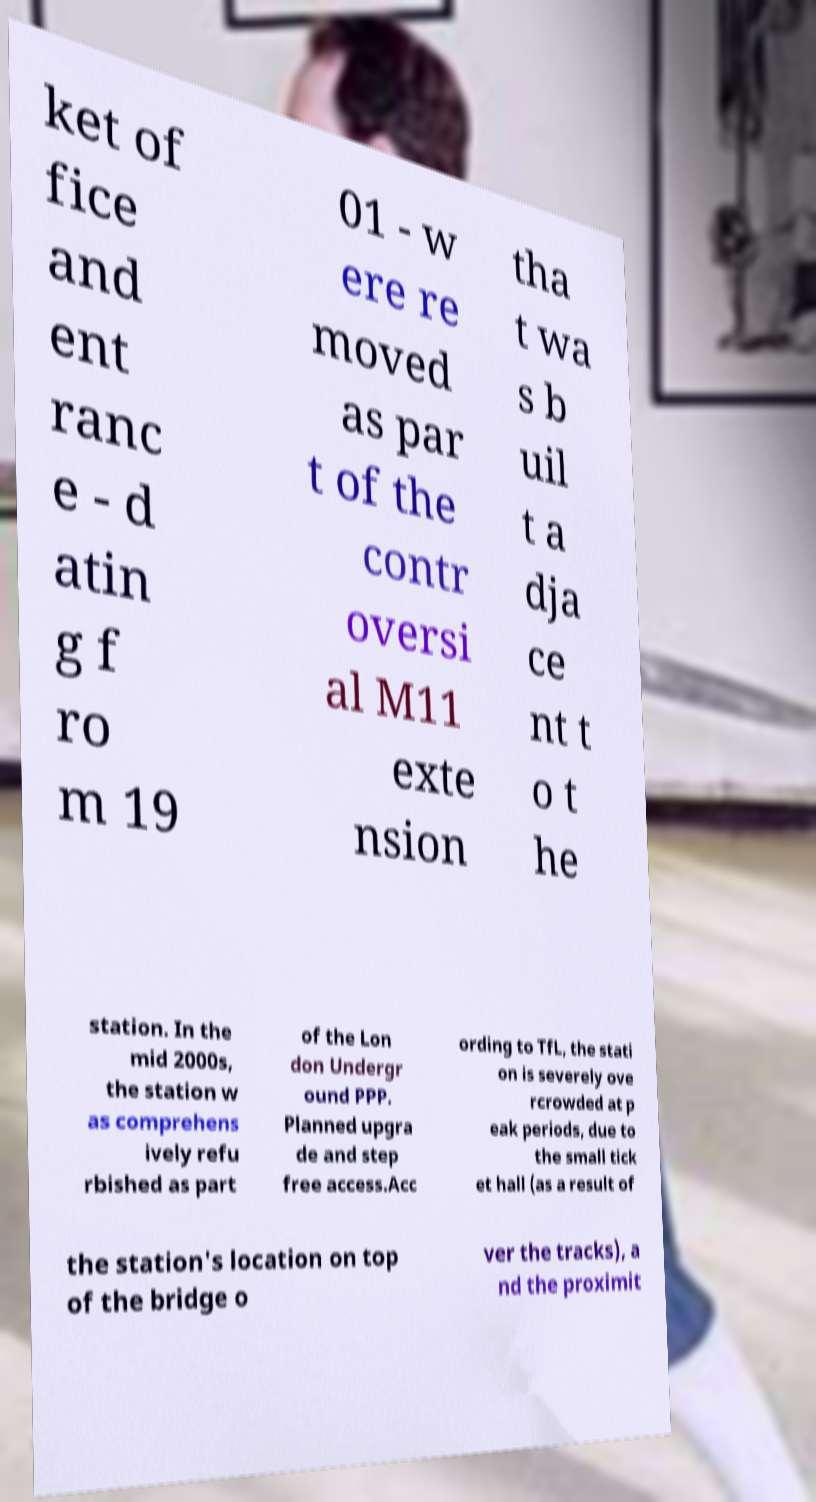Could you assist in decoding the text presented in this image and type it out clearly? ket of fice and ent ranc e - d atin g f ro m 19 01 - w ere re moved as par t of the contr oversi al M11 exte nsion tha t wa s b uil t a dja ce nt t o t he station. In the mid 2000s, the station w as comprehens ively refu rbished as part of the Lon don Undergr ound PPP. Planned upgra de and step free access.Acc ording to TfL, the stati on is severely ove rcrowded at p eak periods, due to the small tick et hall (as a result of the station's location on top of the bridge o ver the tracks), a nd the proximit 